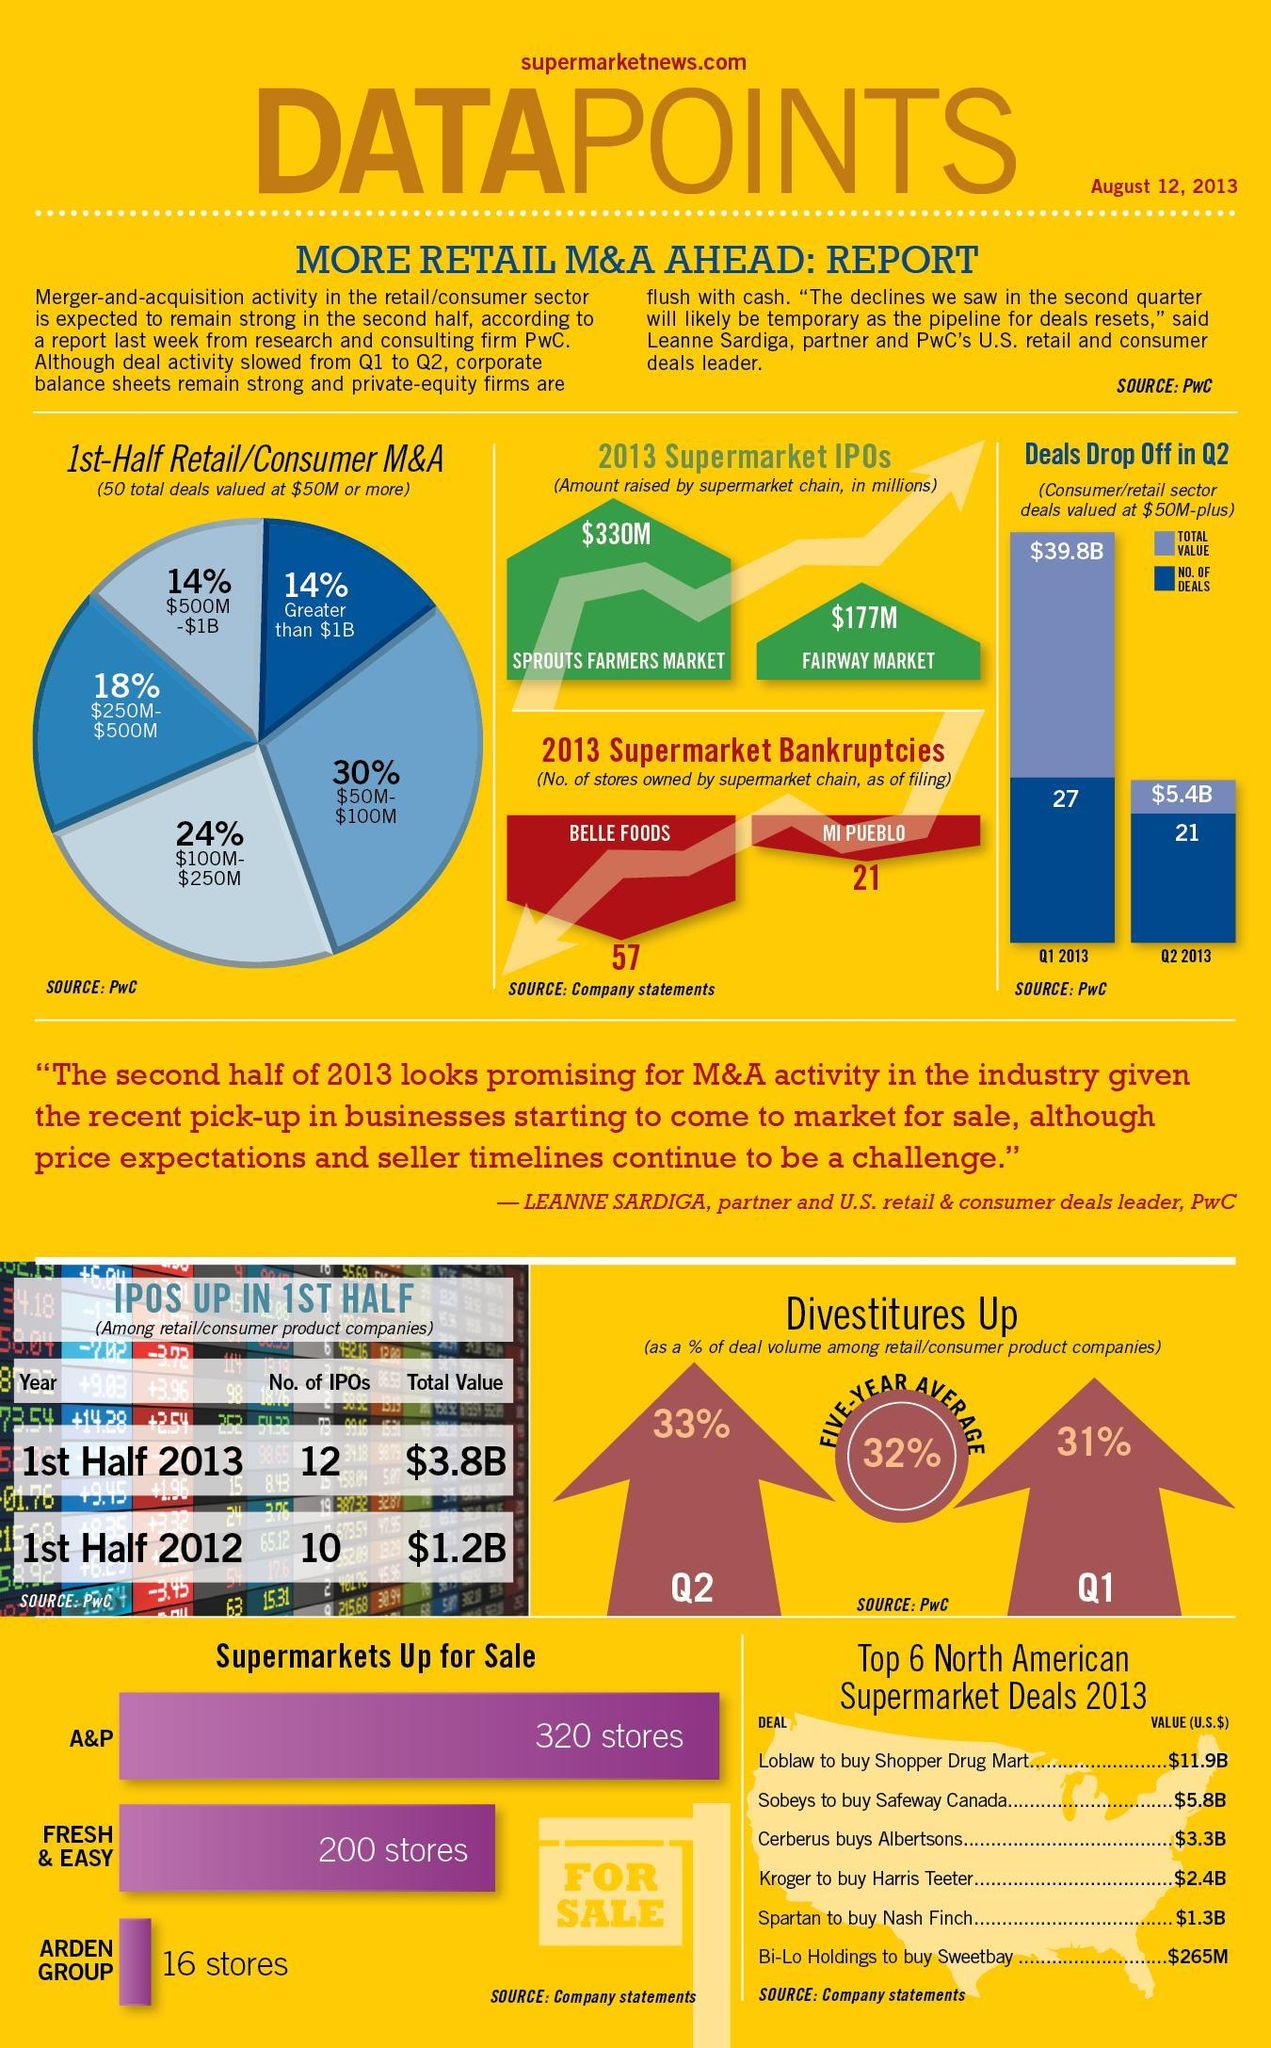What is the total value of deals in Quarter2?
Answer the question with a short phrase. $5.4B Who bought Safeway Canada and at what price? Sobeys, $5.8B How much was the total value of IPOS in the first half 2013, higher than in the first half of 2012($b)? 2.6 What is the amount raised by the Fairway market in 2013? $177m What is the total value of deals in quarter 1, 2013? $39.8B Which was the third highest North American supermarket deal in 2013? Cerberus buys Albertsons Which are the two supermarkets that went bankrupt in 2013? Belle foods, Mi Pueblo Which were the North American super market deals, above $6B ? Loblaw to buy Shopper Drug Mart What is the number of deals in quarter 1, 2013 27 What is the percentage of divestitures in Quarter 1? 31% What is the number of deals in quarter 2, 2013? 21 Which were the 3 supermarkets up for sale? A&P, Fresh & easy, Arden Group In which quarter was the % of divestiture higher? Q2 Who bought Sweetbay and at what price? Bi-Lo Holdings, $265M What is the amount raised by the Sprouts Farmers market in 2013? $330m Which supermarkets put more than 100 stores, up for sale? A&P, Fresh & easy How much more is the number of IPOS in the first half 2013, than in the first half of 2012? 2 Which was the North American supermarket deal below $1 billion, in 2013? Bi-Lo Holdings to buy Sweetbay 